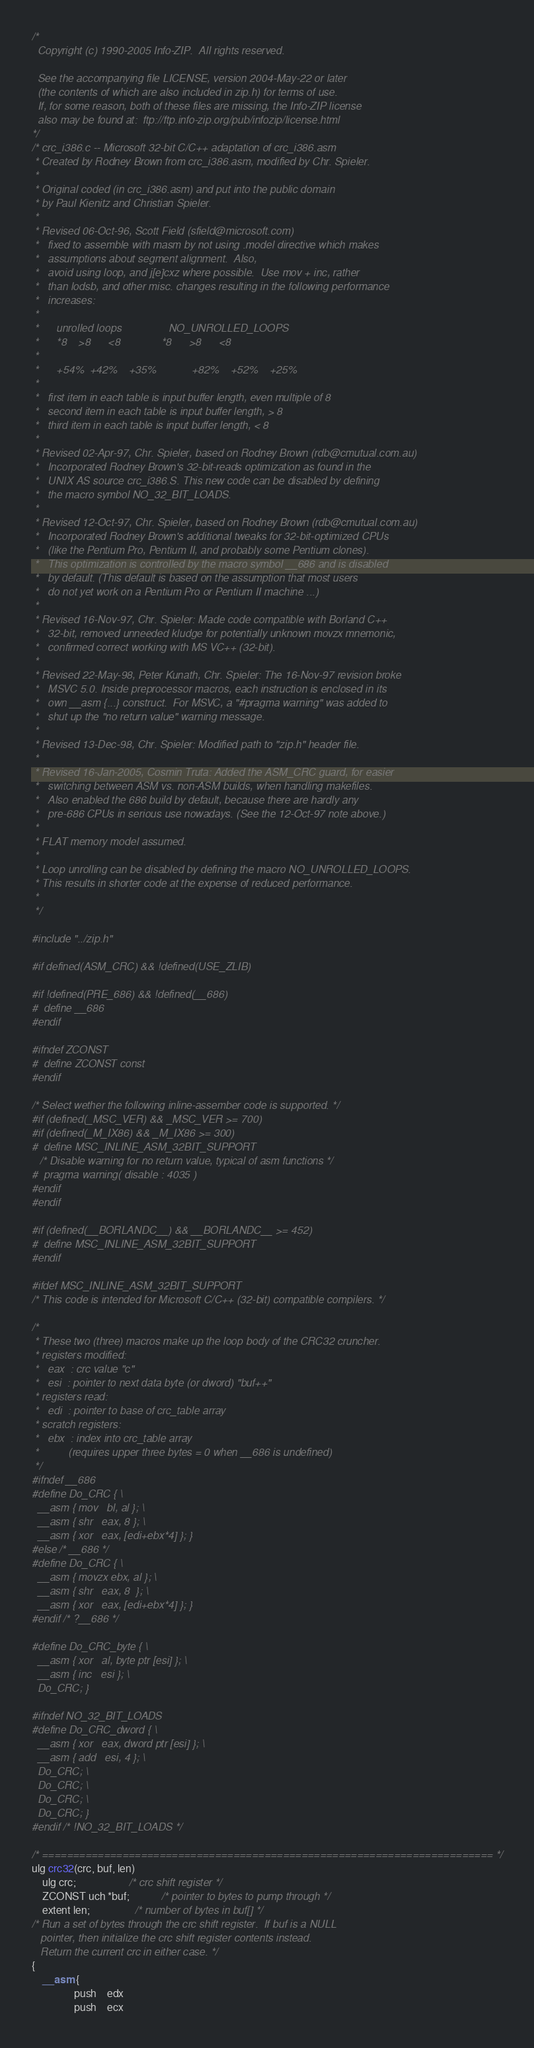Convert code to text. <code><loc_0><loc_0><loc_500><loc_500><_C_>/*
  Copyright (c) 1990-2005 Info-ZIP.  All rights reserved.

  See the accompanying file LICENSE, version 2004-May-22 or later
  (the contents of which are also included in zip.h) for terms of use.
  If, for some reason, both of these files are missing, the Info-ZIP license
  also may be found at:  ftp://ftp.info-zip.org/pub/infozip/license.html
*/
/* crc_i386.c -- Microsoft 32-bit C/C++ adaptation of crc_i386.asm
 * Created by Rodney Brown from crc_i386.asm, modified by Chr. Spieler.
 *
 * Original coded (in crc_i386.asm) and put into the public domain
 * by Paul Kienitz and Christian Spieler.
 *
 * Revised 06-Oct-96, Scott Field (sfield@microsoft.com)
 *   fixed to assemble with masm by not using .model directive which makes
 *   assumptions about segment alignment.  Also,
 *   avoid using loop, and j[e]cxz where possible.  Use mov + inc, rather
 *   than lodsb, and other misc. changes resulting in the following performance
 *   increases:
 *
 *      unrolled loops                NO_UNROLLED_LOOPS
 *      *8    >8      <8              *8      >8      <8
 *
 *      +54%  +42%    +35%            +82%    +52%    +25%
 *
 *   first item in each table is input buffer length, even multiple of 8
 *   second item in each table is input buffer length, > 8
 *   third item in each table is input buffer length, < 8
 *
 * Revised 02-Apr-97, Chr. Spieler, based on Rodney Brown (rdb@cmutual.com.au)
 *   Incorporated Rodney Brown's 32-bit-reads optimization as found in the
 *   UNIX AS source crc_i386.S. This new code can be disabled by defining
 *   the macro symbol NO_32_BIT_LOADS.
 *
 * Revised 12-Oct-97, Chr. Spieler, based on Rodney Brown (rdb@cmutual.com.au)
 *   Incorporated Rodney Brown's additional tweaks for 32-bit-optimized CPUs
 *   (like the Pentium Pro, Pentium II, and probably some Pentium clones).
 *   This optimization is controlled by the macro symbol __686 and is disabled
 *   by default. (This default is based on the assumption that most users
 *   do not yet work on a Pentium Pro or Pentium II machine ...)
 *
 * Revised 16-Nov-97, Chr. Spieler: Made code compatible with Borland C++
 *   32-bit, removed unneeded kludge for potentially unknown movzx mnemonic,
 *   confirmed correct working with MS VC++ (32-bit).
 *
 * Revised 22-May-98, Peter Kunath, Chr. Spieler: The 16-Nov-97 revision broke
 *   MSVC 5.0. Inside preprocessor macros, each instruction is enclosed in its
 *   own __asm {...} construct.  For MSVC, a "#pragma warning" was added to
 *   shut up the "no return value" warning message.
 *
 * Revised 13-Dec-98, Chr. Spieler: Modified path to "zip.h" header file.
 *
 * Revised 16-Jan-2005, Cosmin Truta: Added the ASM_CRC guard, for easier
 *   switching between ASM vs. non-ASM builds, when handling makefiles.
 *   Also enabled the 686 build by default, because there are hardly any
 *   pre-686 CPUs in serious use nowadays. (See the 12-Oct-97 note above.)
 *
 * FLAT memory model assumed.
 *
 * Loop unrolling can be disabled by defining the macro NO_UNROLLED_LOOPS.
 * This results in shorter code at the expense of reduced performance.
 *
 */

#include "../zip.h"

#if defined(ASM_CRC) && !defined(USE_ZLIB)

#if !defined(PRE_686) && !defined(__686)
#  define __686
#endif

#ifndef ZCONST
#  define ZCONST const
#endif

/* Select wether the following inline-assember code is supported. */
#if (defined(_MSC_VER) && _MSC_VER >= 700)
#if (defined(_M_IX86) && _M_IX86 >= 300)
#  define MSC_INLINE_ASM_32BIT_SUPPORT
   /* Disable warning for no return value, typical of asm functions */
#  pragma warning( disable : 4035 )
#endif
#endif

#if (defined(__BORLANDC__) && __BORLANDC__ >= 452)
#  define MSC_INLINE_ASM_32BIT_SUPPORT
#endif

#ifdef MSC_INLINE_ASM_32BIT_SUPPORT
/* This code is intended for Microsoft C/C++ (32-bit) compatible compilers. */

/*
 * These two (three) macros make up the loop body of the CRC32 cruncher.
 * registers modified:
 *   eax  : crc value "c"
 *   esi  : pointer to next data byte (or dword) "buf++"
 * registers read:
 *   edi  : pointer to base of crc_table array
 * scratch registers:
 *   ebx  : index into crc_table array
 *          (requires upper three bytes = 0 when __686 is undefined)
 */
#ifndef __686
#define Do_CRC { \
  __asm { mov   bl, al }; \
  __asm { shr   eax, 8 }; \
  __asm { xor   eax, [edi+ebx*4] }; }
#else /* __686 */
#define Do_CRC { \
  __asm { movzx ebx, al }; \
  __asm { shr   eax, 8  }; \
  __asm { xor   eax, [edi+ebx*4] }; }
#endif /* ?__686 */

#define Do_CRC_byte { \
  __asm { xor   al, byte ptr [esi] }; \
  __asm { inc   esi }; \
  Do_CRC; }

#ifndef NO_32_BIT_LOADS
#define Do_CRC_dword { \
  __asm { xor   eax, dword ptr [esi] }; \
  __asm { add   esi, 4 }; \
  Do_CRC; \
  Do_CRC; \
  Do_CRC; \
  Do_CRC; }
#endif /* !NO_32_BIT_LOADS */

/* ========================================================================= */
ulg crc32(crc, buf, len)
    ulg crc;                    /* crc shift register */
    ZCONST uch *buf;            /* pointer to bytes to pump through */
    extent len;                 /* number of bytes in buf[] */
/* Run a set of bytes through the crc shift register.  If buf is a NULL
   pointer, then initialize the crc shift register contents instead.
   Return the current crc in either case. */
{
    __asm {
                push    edx
                push    ecx
</code> 